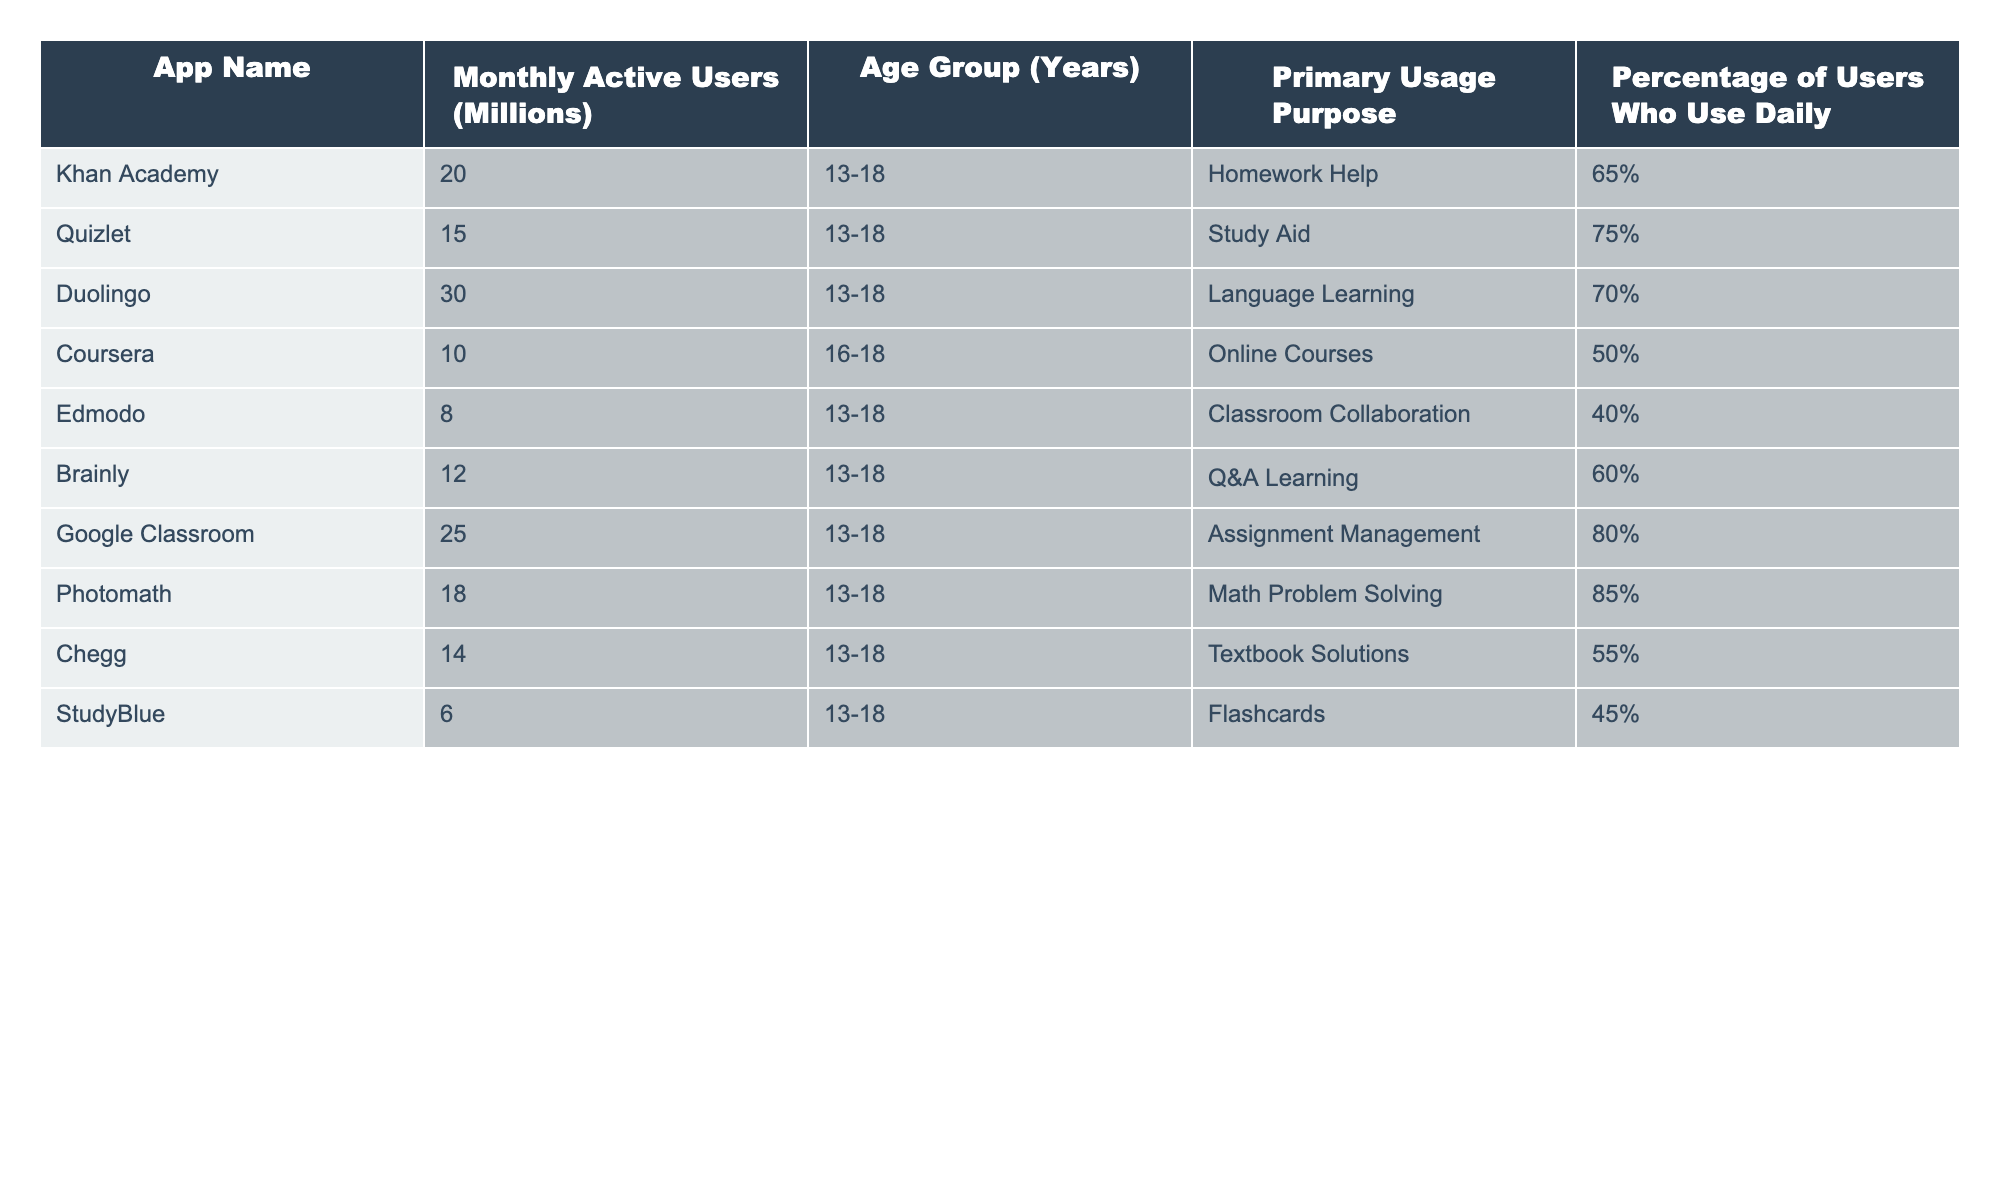What app has the highest number of monthly active users? Looking at the "Monthly Active Users" column, Duolingo shows the highest value at 30 million users.
Answer: Duolingo Which app has the lowest percentage of daily users? In the "Percentage of Users Who Use Daily" column, Edmodo has the lowest percentage at 40%.
Answer: Edmodo What is the total number of monthly active users across all apps listed? Adding up the values from the "Monthly Active Users" column, the sum is 20 + 15 + 30 + 10 + 8 + 12 + 25 + 18 + 14 + 6 =  158 million.
Answer: 158 million Which app is primarily used for homework help? The table specifies that Khan Academy is the app aimed at homework help in the "Primary Usage Purpose" column.
Answer: Khan Academy Is there any app that has more than 80% of its users using it daily? By checking the "Percentage of Users Who Use Daily" column, both Google Classroom and Photomath have percentages of 80% and 85%, respectively, indicating that yes, there are apps with more than 80% of daily users.
Answer: Yes What is the average percentage of daily users for all the apps listed? Adding the percentages of daily users: 65 + 75 + 70 + 50 + 40 + 60 + 80 + 85 + 55 + 45 =  725, and dividing by the number of apps (10) gives an average of 72.5%.
Answer: 72.5% Which age group uses the most educational apps? All apps listed target the age group of 13-18 years, indicating no specific age group stands out.
Answer: 13-18 years How many apps have a primary usage purpose related to studying or learning? Counting the entries under "Primary Usage Purpose," we find that all listed apps are related to studying or learning, confirming that all 10 apps serve this purpose.
Answer: 10 apps Which app is mainly focused on language learning, and what is its usage percentage? Duolingo focuses on language learning, and the "Percentage of Users Who Use Daily" for Duolingo is 70%.
Answer: Duolingo, 70% 